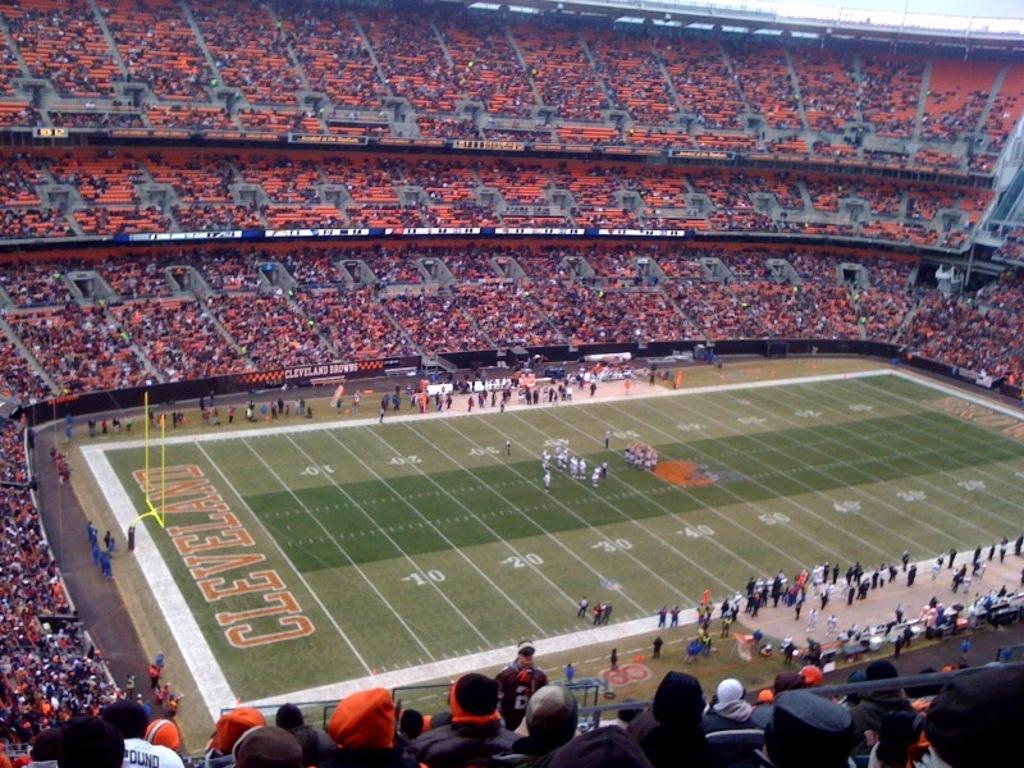<image>
Describe the image concisely. Cleveland is displayed in large letters in the end zone of this football stadium. 